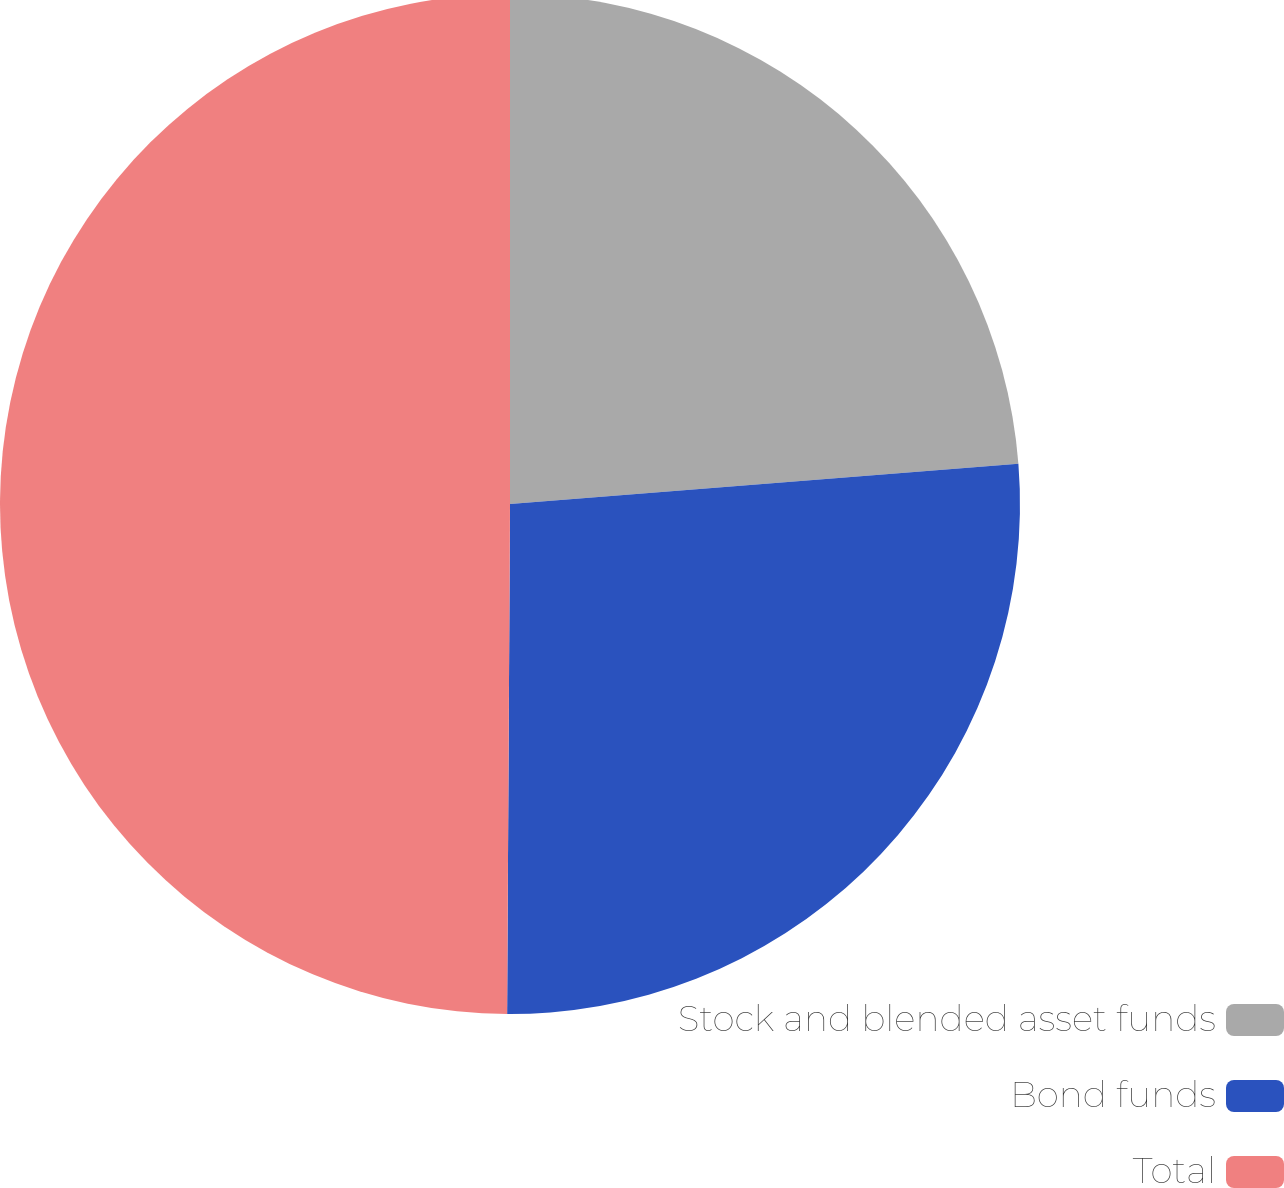<chart> <loc_0><loc_0><loc_500><loc_500><pie_chart><fcel>Stock and blended asset funds<fcel>Bond funds<fcel>Total<nl><fcel>23.74%<fcel>26.35%<fcel>49.91%<nl></chart> 